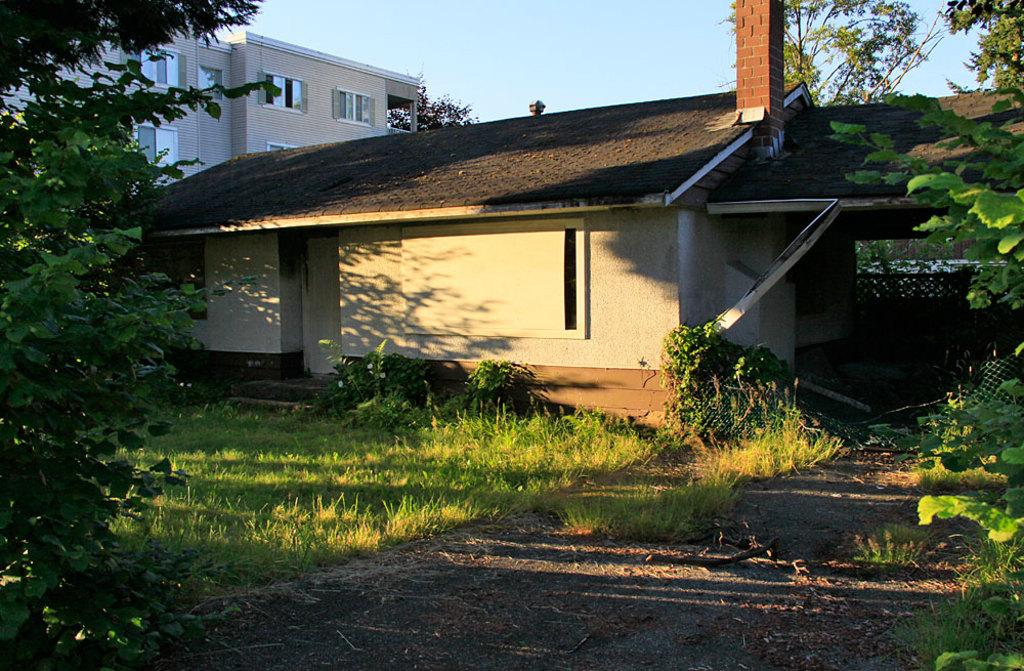What type of structure is present in the image? There is a house and a building in the image. What type of natural environment is visible in the image? There are trees and grass in the image. What is visible in the sky in the image? The sky is visible in the image. What type of need can be seen being used by the queen in the image? There is no queen or any type of need present in the image. How does the grass stretch across the image? The grass does not stretch across the image; it is stationary and visible in the image. 